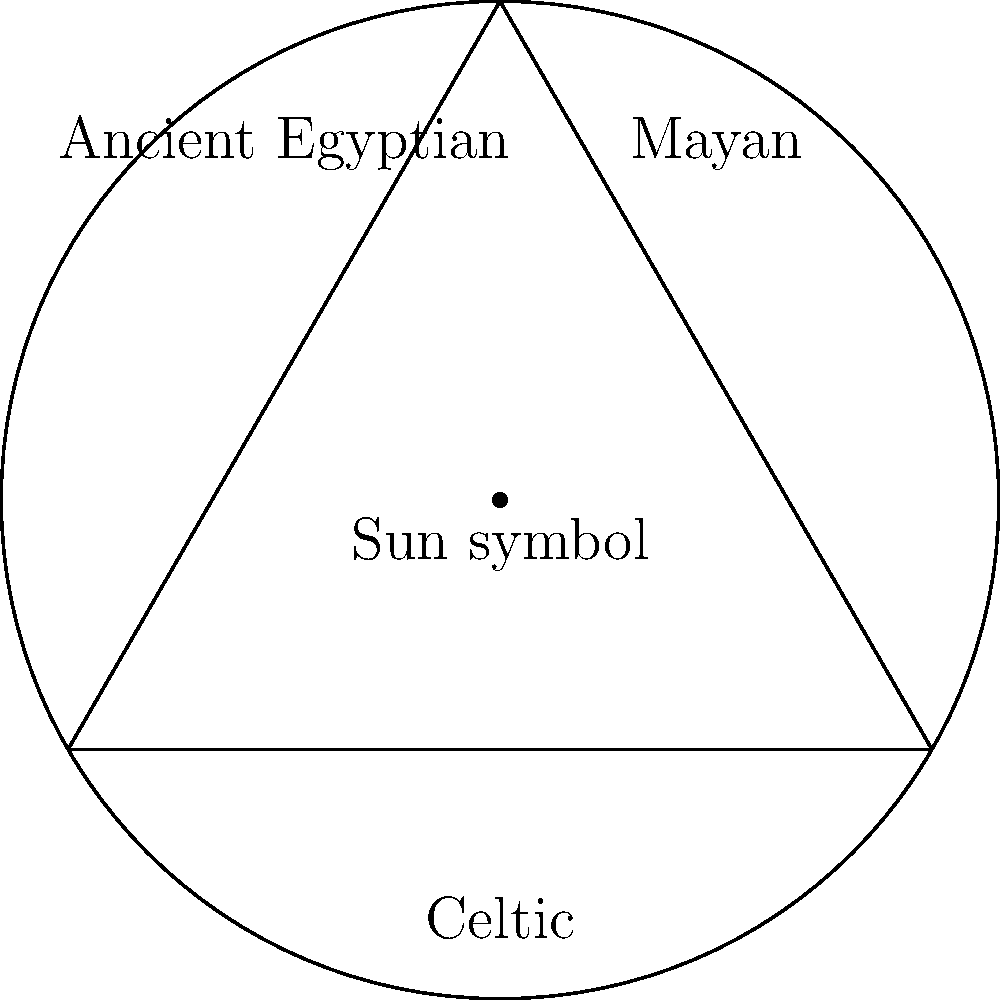In the Venn diagram above, the intersection of circular patterns from Ancient Egyptian, Mayan, and Celtic cultures is represented by a sun symbol. How does this representation challenge or support the idea of cultural universality in symbolic representations? To answer this question, we need to consider several factors:

1. Universality of circular patterns: The Venn diagram shows that circular patterns are present in three distinct cultures (Ancient Egyptian, Mayan, and Celtic), suggesting a degree of universality.

2. Sun symbol at the intersection: The placement of the sun symbol at the intersection of all three cultures implies that this particular circular pattern has a shared significance across these diverse civilizations.

3. Cultural diffusion vs. independent development: We need to consider whether this similarity is due to cultural exchange or independent development based on common human experiences (e.g., observing the sun).

4. Symbolic meaning: The sun is often associated with life, power, and divine forces in many cultures, which could explain its prevalence.

5. Challenging cultural relativism: This representation challenges the idea that all cultural symbols are entirely unique to their respective societies.

6. Supporting universality: The diagram supports the notion that some symbols, particularly those based on natural phenomena, may have universal or near-universal significance.

7. Limitations of the representation: It's important to note that this diagram simplifies complex cultural relationships and doesn't account for potential differences in the specific representations or meanings of sun symbols in each culture.

Given the persona of a cultural studies scholar who emphasizes the universality of certain cultural symbols, the answer would likely focus on how this representation supports the idea of cross-cultural similarities in symbolic representations, particularly those derived from shared human experiences of natural phenomena.
Answer: Supports universality of sun symbolism across cultures 